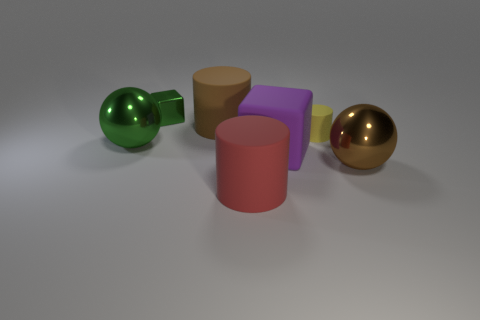Add 2 purple blocks. How many objects exist? 9 Subtract all big brown rubber cylinders. How many cylinders are left? 2 Subtract all purple blocks. How many blocks are left? 1 Add 1 large green metal balls. How many large green metal balls are left? 2 Add 2 green spheres. How many green spheres exist? 3 Subtract 1 yellow cylinders. How many objects are left? 6 Subtract all balls. How many objects are left? 5 Subtract 1 cylinders. How many cylinders are left? 2 Subtract all red blocks. Subtract all cyan cylinders. How many blocks are left? 2 Subtract all yellow cylinders. Subtract all large purple spheres. How many objects are left? 6 